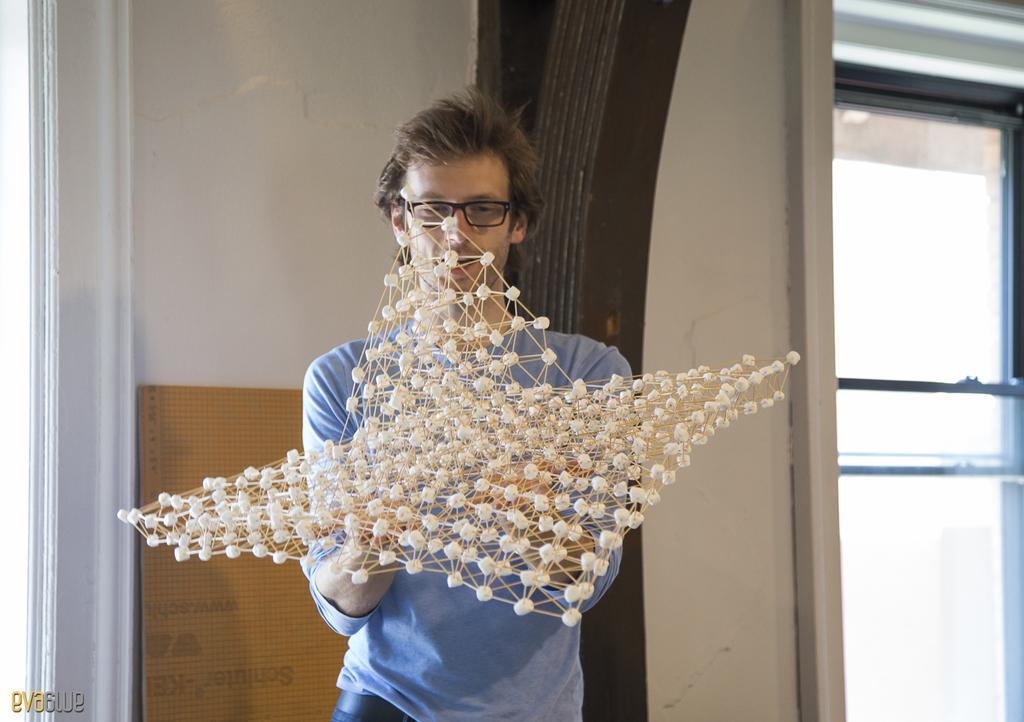What can be seen in the image? There is a person in the image. What is the person holding? The person is holding something, but the facts do not specify what it is. What is the person wearing? The person is wearing a blue t-shirt. What can be seen in the background of the image? There is a window, a brown board, and a wall in the background of the image. What type of waves can be seen crashing against the shore in the image? There are no waves or shore visible in the image; it features a person holding something and wearing a blue t-shirt, with a window, brown board, and wall in the background. 